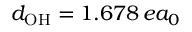<formula> <loc_0><loc_0><loc_500><loc_500>d _ { O H } = 1 . 6 7 8 \, e a _ { 0 }</formula> 